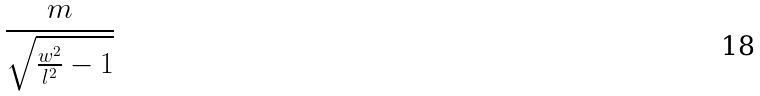Convert formula to latex. <formula><loc_0><loc_0><loc_500><loc_500>\frac { m } { \sqrt { \frac { w ^ { 2 } } { l ^ { 2 } } - 1 } }</formula> 